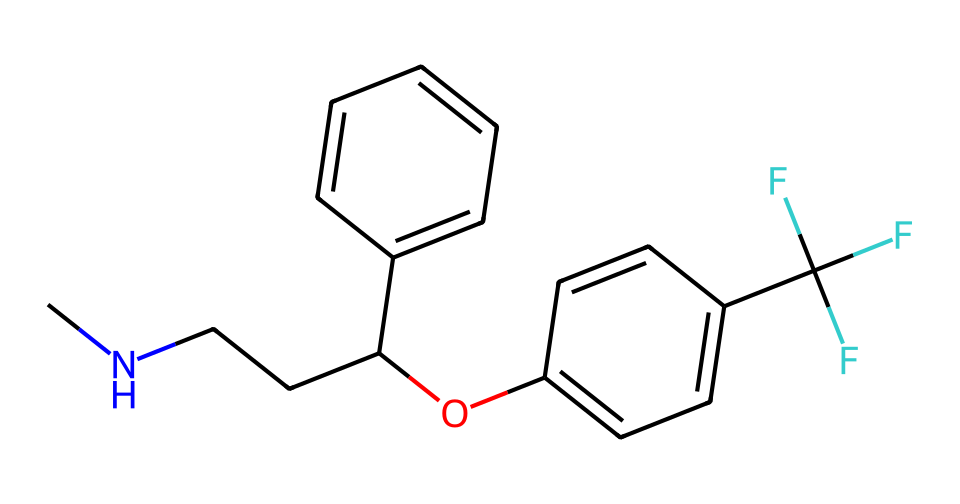What is the molecular formula of fluoxetine? To find the molecular formula, we can count the number of each type of atom in the SMILES representation. The components indicate carbon (C), hydrogen (H), oxygen (O), and nitrogen (N). Counting them gives us: C = 17, H = 18, N = 1, O = 1. Therefore, the molecular formula is C17H18F3N
Answer: C17H18F3N How many rings are present in the chemical structure of fluoxetine? Analyzing the SMILES representation, we can identify that there are two distinct aromatic rings in the structure. These are indicated by the 'c' symbols (for aromatic carbon). Therefore, the number of rings is 2.
Answer: 2 What functional group is present in fluoxetine? Examining the SMILES structure, we notice the presence of an alcohol group (indicated by the -OH functional group), which is linked to the carbon chain as indicated in the structure. Therefore, the functional group present is an alcohol.
Answer: alcohol What is the presence of halogens in fluoxetine? In the SMILES representation, we see a section that indicates the presence of trifluoromethyl (-CF3) group, which contains three fluorine (F) atoms. Fluorine is a halogen, so yes, fluoxetine contains halogens.
Answer: yes Is fluoxetine a polar or nonpolar molecule? The presence of an alcohol group and the fluorinated carbon suggests that fluoxetine has polar characteristics due to the electronegative atoms (oxygen and fluorine). The overall structure indicates that it has a polar nature.
Answer: polar What type of antidepressant is fluoxetine classified as? Fluoxetine is classified as a selective serotonin reuptake inhibitor (SSRI), which helps increase levels of serotonin in the brain, useful in treating depression and other mood disorders.
Answer: SSRI How many carbon atoms are in fluoxetine's structure? By closely examining the SMILES representation, we can count the number of carbon atoms (C) present; there are a total of 17 carbon atoms in the structure.
Answer: 17 